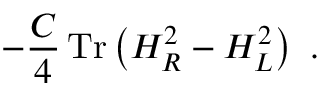<formula> <loc_0><loc_0><loc_500><loc_500>- \frac { C } { 4 } \, T r \left ( H _ { R } ^ { 2 } - H _ { L } ^ { 2 } \right ) \ .</formula> 